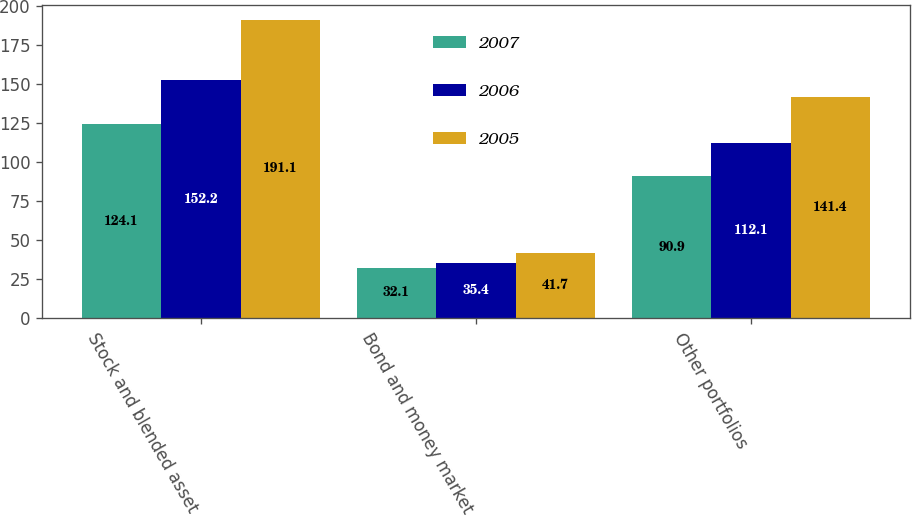Convert chart to OTSL. <chart><loc_0><loc_0><loc_500><loc_500><stacked_bar_chart><ecel><fcel>Stock and blended asset<fcel>Bond and money market<fcel>Other portfolios<nl><fcel>2007<fcel>124.1<fcel>32.1<fcel>90.9<nl><fcel>2006<fcel>152.2<fcel>35.4<fcel>112.1<nl><fcel>2005<fcel>191.1<fcel>41.7<fcel>141.4<nl></chart> 